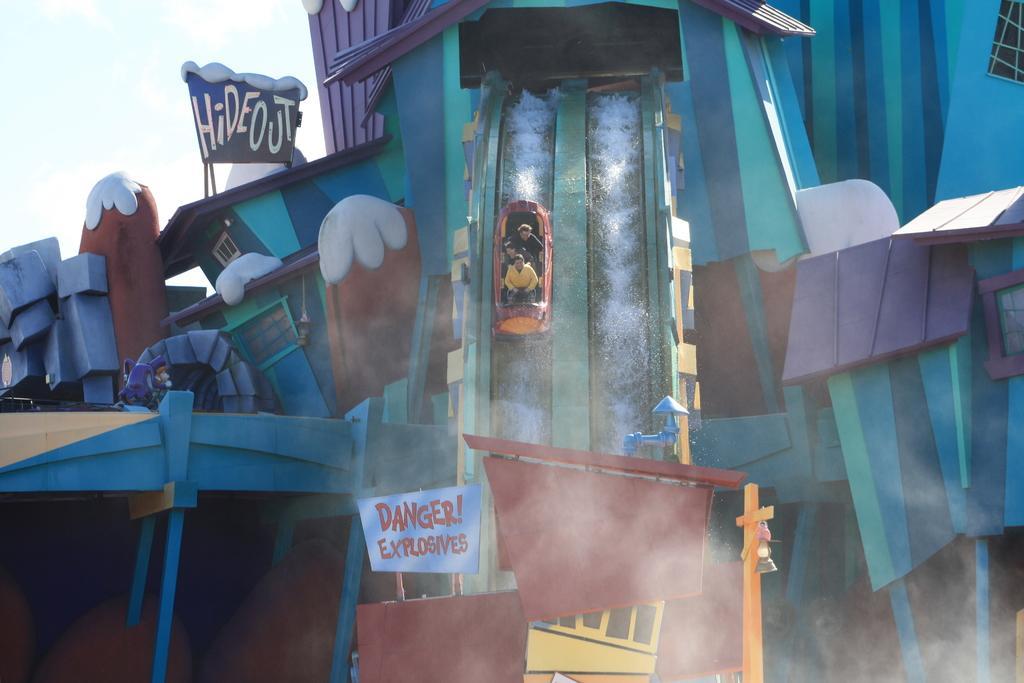Could you give a brief overview of what you see in this image? In this image I can see a water slide. I can also see three persons sitting in the boat. Background I can see sky in white color. 